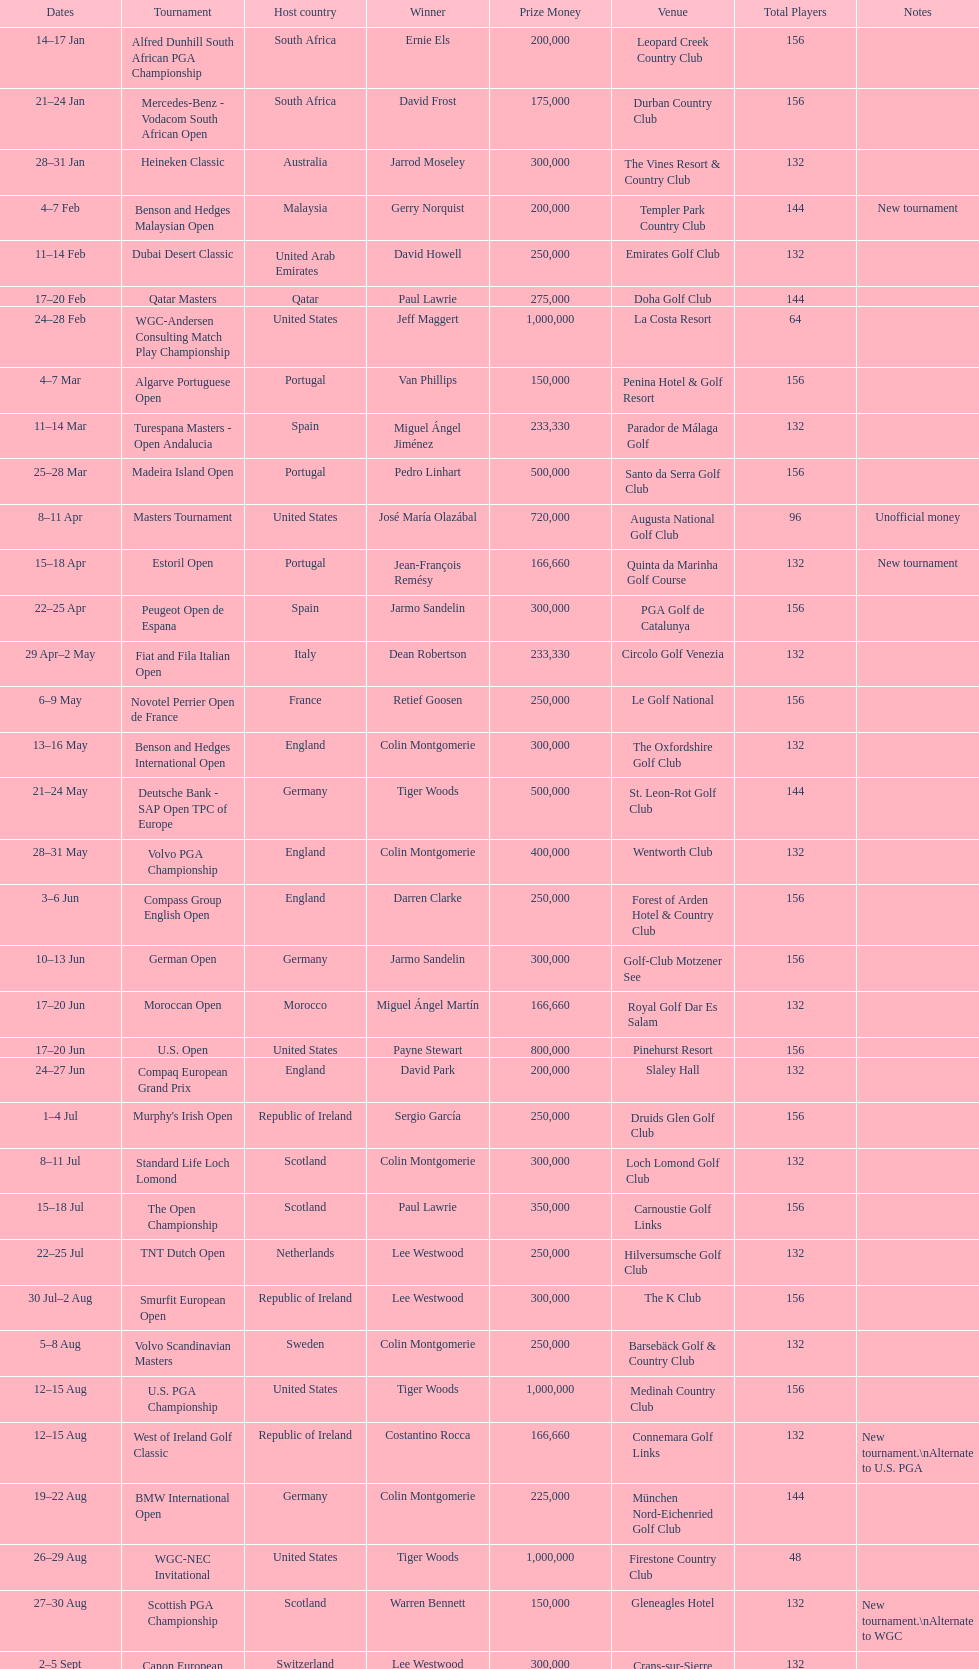What was the length of the estoril open event? 3 days. 